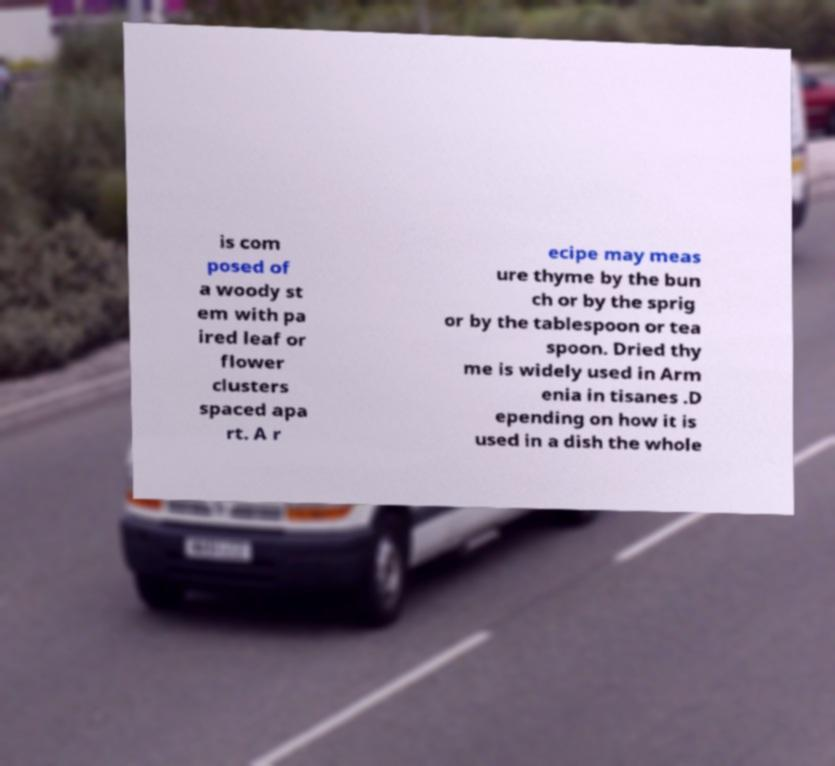For documentation purposes, I need the text within this image transcribed. Could you provide that? is com posed of a woody st em with pa ired leaf or flower clusters spaced apa rt. A r ecipe may meas ure thyme by the bun ch or by the sprig or by the tablespoon or tea spoon. Dried thy me is widely used in Arm enia in tisanes .D epending on how it is used in a dish the whole 